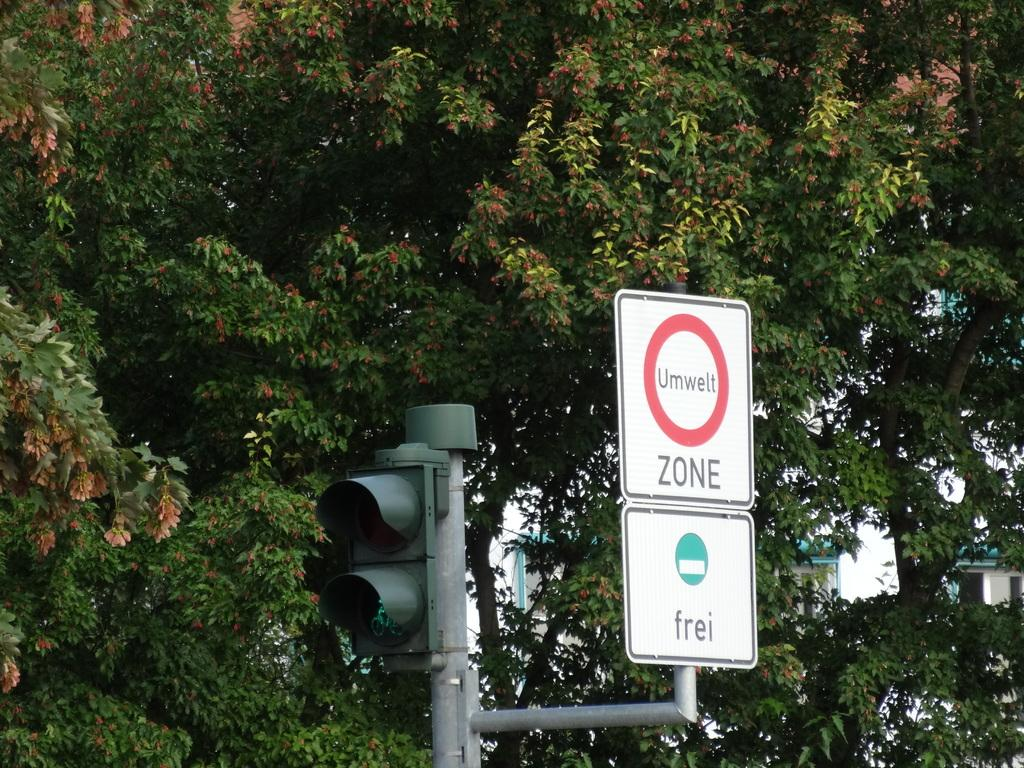<image>
Relay a brief, clear account of the picture shown. a sign that has the word zone on it 